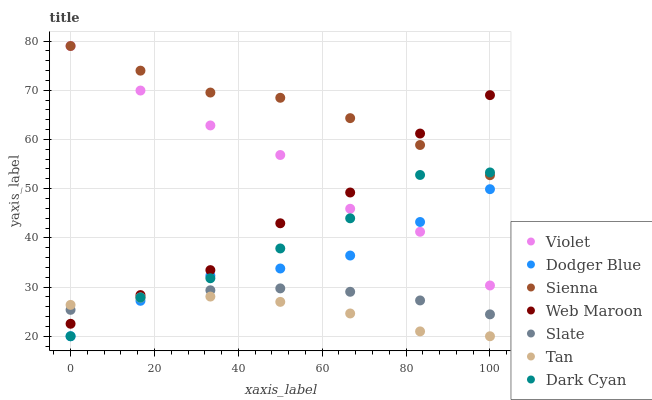Does Tan have the minimum area under the curve?
Answer yes or no. Yes. Does Sienna have the maximum area under the curve?
Answer yes or no. Yes. Does Web Maroon have the minimum area under the curve?
Answer yes or no. No. Does Web Maroon have the maximum area under the curve?
Answer yes or no. No. Is Slate the smoothest?
Answer yes or no. Yes. Is Violet the roughest?
Answer yes or no. Yes. Is Web Maroon the smoothest?
Answer yes or no. No. Is Web Maroon the roughest?
Answer yes or no. No. Does Dodger Blue have the lowest value?
Answer yes or no. Yes. Does Web Maroon have the lowest value?
Answer yes or no. No. Does Violet have the highest value?
Answer yes or no. Yes. Does Web Maroon have the highest value?
Answer yes or no. No. Is Dark Cyan less than Web Maroon?
Answer yes or no. Yes. Is Violet greater than Slate?
Answer yes or no. Yes. Does Sienna intersect Web Maroon?
Answer yes or no. Yes. Is Sienna less than Web Maroon?
Answer yes or no. No. Is Sienna greater than Web Maroon?
Answer yes or no. No. Does Dark Cyan intersect Web Maroon?
Answer yes or no. No. 